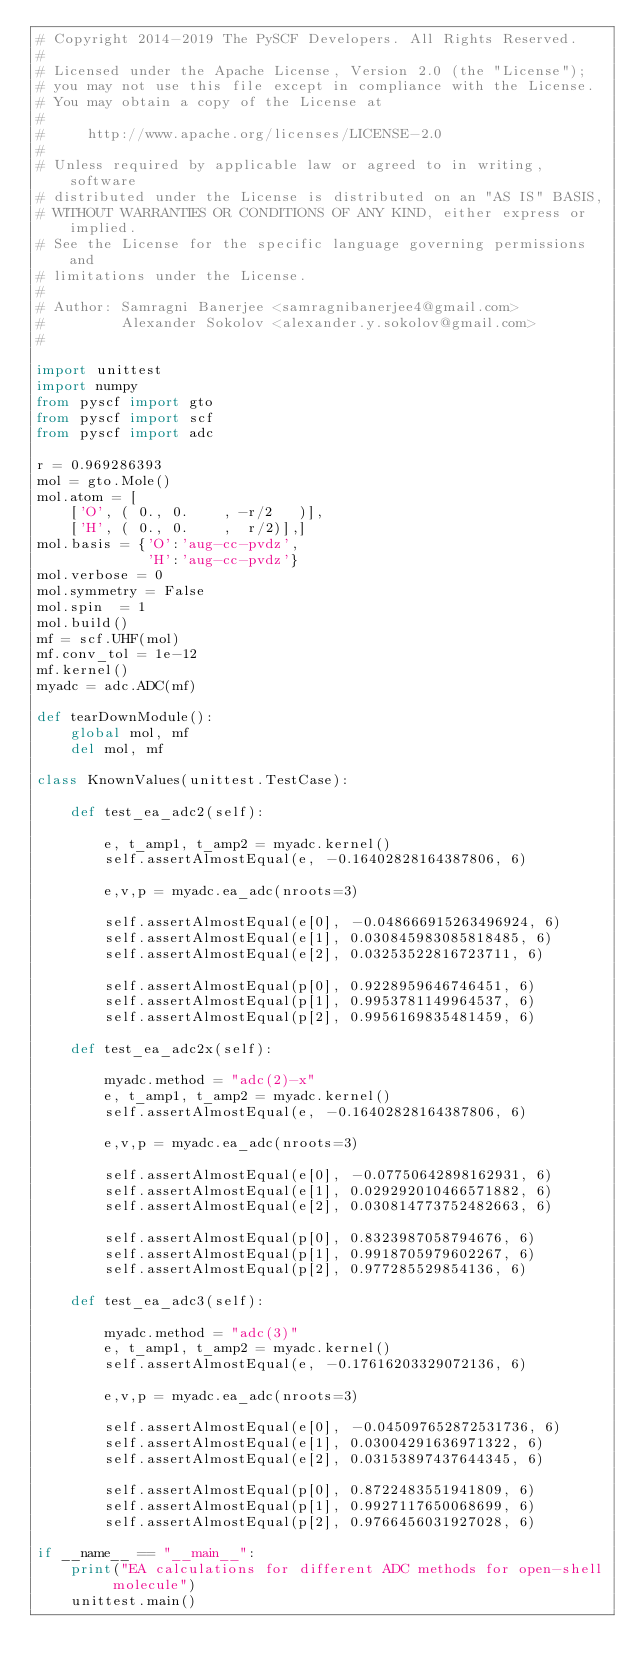<code> <loc_0><loc_0><loc_500><loc_500><_Python_># Copyright 2014-2019 The PySCF Developers. All Rights Reserved.
#
# Licensed under the Apache License, Version 2.0 (the "License");
# you may not use this file except in compliance with the License.
# You may obtain a copy of the License at
#
#     http://www.apache.org/licenses/LICENSE-2.0
#
# Unless required by applicable law or agreed to in writing, software
# distributed under the License is distributed on an "AS IS" BASIS,
# WITHOUT WARRANTIES OR CONDITIONS OF ANY KIND, either express or implied.
# See the License for the specific language governing permissions and
# limitations under the License.
#
# Author: Samragni Banerjee <samragnibanerjee4@gmail.com>
#         Alexander Sokolov <alexander.y.sokolov@gmail.com>
#

import unittest
import numpy
from pyscf import gto
from pyscf import scf
from pyscf import adc

r = 0.969286393
mol = gto.Mole()
mol.atom = [
    ['O', ( 0., 0.    , -r/2   )],
    ['H', ( 0., 0.    ,  r/2)],]
mol.basis = {'O':'aug-cc-pvdz',
             'H':'aug-cc-pvdz'}
mol.verbose = 0
mol.symmetry = False
mol.spin  = 1
mol.build()
mf = scf.UHF(mol)
mf.conv_tol = 1e-12
mf.kernel()
myadc = adc.ADC(mf)

def tearDownModule():
    global mol, mf
    del mol, mf

class KnownValues(unittest.TestCase):

    def test_ea_adc2(self):
  
        e, t_amp1, t_amp2 = myadc.kernel()
        self.assertAlmostEqual(e, -0.16402828164387806, 6)

        e,v,p = myadc.ea_adc(nroots=3)

        self.assertAlmostEqual(e[0], -0.048666915263496924, 6)
        self.assertAlmostEqual(e[1], 0.030845983085818485, 6)
        self.assertAlmostEqual(e[2], 0.03253522816723711, 6)

        self.assertAlmostEqual(p[0], 0.9228959646746451, 6)
        self.assertAlmostEqual(p[1], 0.9953781149964537, 6)
        self.assertAlmostEqual(p[2], 0.9956169835481459, 6)

    def test_ea_adc2x(self):
  
        myadc.method = "adc(2)-x"
        e, t_amp1, t_amp2 = myadc.kernel()
        self.assertAlmostEqual(e, -0.16402828164387806, 6)

        e,v,p = myadc.ea_adc(nroots=3)

        self.assertAlmostEqual(e[0], -0.07750642898162931, 6)
        self.assertAlmostEqual(e[1], 0.029292010466571882, 6)
        self.assertAlmostEqual(e[2], 0.030814773752482663, 6)

        self.assertAlmostEqual(p[0], 0.8323987058794676, 6)
        self.assertAlmostEqual(p[1], 0.9918705979602267, 6)
        self.assertAlmostEqual(p[2], 0.977285529854136, 6)

    def test_ea_adc3(self):
  
        myadc.method = "adc(3)"
        e, t_amp1, t_amp2 = myadc.kernel()
        self.assertAlmostEqual(e, -0.17616203329072136, 6)

        e,v,p = myadc.ea_adc(nroots=3)

        self.assertAlmostEqual(e[0], -0.045097652872531736, 6)
        self.assertAlmostEqual(e[1], 0.03004291636971322, 6)
        self.assertAlmostEqual(e[2], 0.03153897437644345, 6)

        self.assertAlmostEqual(p[0], 0.8722483551941809, 6)
        self.assertAlmostEqual(p[1], 0.9927117650068699, 6)
        self.assertAlmostEqual(p[2], 0.9766456031927028, 6)
      
if __name__ == "__main__":
    print("EA calculations for different ADC methods for open-shell molecule")
    unittest.main()
</code> 